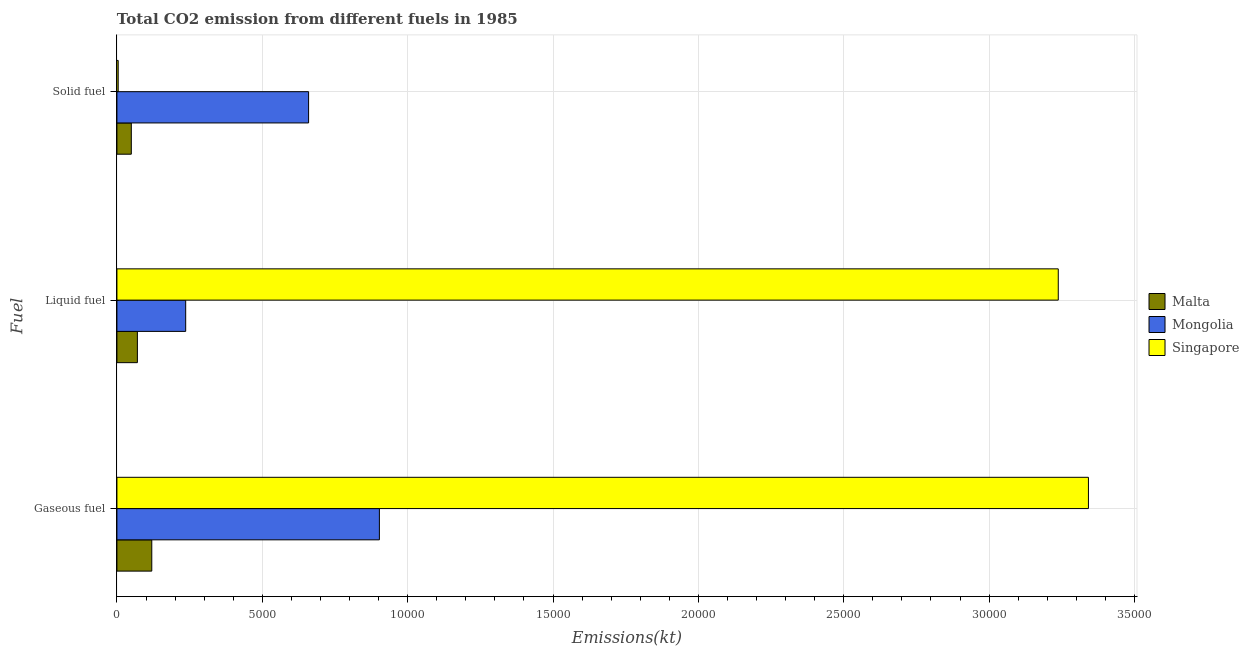How many different coloured bars are there?
Your answer should be compact. 3. How many groups of bars are there?
Ensure brevity in your answer.  3. Are the number of bars per tick equal to the number of legend labels?
Offer a terse response. Yes. Are the number of bars on each tick of the Y-axis equal?
Offer a terse response. Yes. How many bars are there on the 3rd tick from the top?
Your answer should be compact. 3. What is the label of the 2nd group of bars from the top?
Offer a terse response. Liquid fuel. What is the amount of co2 emissions from gaseous fuel in Mongolia?
Make the answer very short. 9028.15. Across all countries, what is the maximum amount of co2 emissions from liquid fuel?
Ensure brevity in your answer.  3.24e+04. Across all countries, what is the minimum amount of co2 emissions from gaseous fuel?
Keep it short and to the point. 1199.11. In which country was the amount of co2 emissions from solid fuel maximum?
Ensure brevity in your answer.  Mongolia. In which country was the amount of co2 emissions from gaseous fuel minimum?
Make the answer very short. Malta. What is the total amount of co2 emissions from liquid fuel in the graph?
Provide a succinct answer. 3.54e+04. What is the difference between the amount of co2 emissions from gaseous fuel in Malta and that in Singapore?
Your answer should be very brief. -3.22e+04. What is the difference between the amount of co2 emissions from solid fuel in Mongolia and the amount of co2 emissions from liquid fuel in Singapore?
Provide a short and direct response. -2.58e+04. What is the average amount of co2 emissions from solid fuel per country?
Give a very brief answer. 2377.44. What is the difference between the amount of co2 emissions from liquid fuel and amount of co2 emissions from solid fuel in Malta?
Give a very brief answer. 209.02. In how many countries, is the amount of co2 emissions from liquid fuel greater than 16000 kt?
Ensure brevity in your answer.  1. What is the ratio of the amount of co2 emissions from gaseous fuel in Mongolia to that in Singapore?
Provide a short and direct response. 0.27. Is the amount of co2 emissions from liquid fuel in Malta less than that in Mongolia?
Ensure brevity in your answer.  Yes. Is the difference between the amount of co2 emissions from solid fuel in Mongolia and Singapore greater than the difference between the amount of co2 emissions from liquid fuel in Mongolia and Singapore?
Make the answer very short. Yes. What is the difference between the highest and the second highest amount of co2 emissions from solid fuel?
Provide a short and direct response. 6098.22. What is the difference between the highest and the lowest amount of co2 emissions from gaseous fuel?
Make the answer very short. 3.22e+04. In how many countries, is the amount of co2 emissions from liquid fuel greater than the average amount of co2 emissions from liquid fuel taken over all countries?
Keep it short and to the point. 1. Is the sum of the amount of co2 emissions from liquid fuel in Singapore and Malta greater than the maximum amount of co2 emissions from gaseous fuel across all countries?
Keep it short and to the point. No. What does the 1st bar from the top in Gaseous fuel represents?
Ensure brevity in your answer.  Singapore. What does the 3rd bar from the bottom in Solid fuel represents?
Give a very brief answer. Singapore. How many countries are there in the graph?
Your answer should be compact. 3. What is the difference between two consecutive major ticks on the X-axis?
Provide a succinct answer. 5000. Are the values on the major ticks of X-axis written in scientific E-notation?
Provide a short and direct response. No. Does the graph contain grids?
Offer a terse response. Yes. Where does the legend appear in the graph?
Your answer should be very brief. Center right. How many legend labels are there?
Your answer should be compact. 3. How are the legend labels stacked?
Ensure brevity in your answer.  Vertical. What is the title of the graph?
Your answer should be compact. Total CO2 emission from different fuels in 1985. What is the label or title of the X-axis?
Offer a terse response. Emissions(kt). What is the label or title of the Y-axis?
Your answer should be compact. Fuel. What is the Emissions(kt) in Malta in Gaseous fuel?
Ensure brevity in your answer.  1199.11. What is the Emissions(kt) in Mongolia in Gaseous fuel?
Provide a succinct answer. 9028.15. What is the Emissions(kt) in Singapore in Gaseous fuel?
Ensure brevity in your answer.  3.34e+04. What is the Emissions(kt) in Malta in Liquid fuel?
Offer a very short reply. 704.06. What is the Emissions(kt) of Mongolia in Liquid fuel?
Keep it short and to the point. 2365.22. What is the Emissions(kt) of Singapore in Liquid fuel?
Provide a short and direct response. 3.24e+04. What is the Emissions(kt) of Malta in Solid fuel?
Ensure brevity in your answer.  495.05. What is the Emissions(kt) in Mongolia in Solid fuel?
Provide a succinct answer. 6593.27. What is the Emissions(kt) of Singapore in Solid fuel?
Make the answer very short. 44. Across all Fuel, what is the maximum Emissions(kt) of Malta?
Provide a succinct answer. 1199.11. Across all Fuel, what is the maximum Emissions(kt) in Mongolia?
Provide a short and direct response. 9028.15. Across all Fuel, what is the maximum Emissions(kt) in Singapore?
Give a very brief answer. 3.34e+04. Across all Fuel, what is the minimum Emissions(kt) in Malta?
Give a very brief answer. 495.05. Across all Fuel, what is the minimum Emissions(kt) in Mongolia?
Your answer should be compact. 2365.22. Across all Fuel, what is the minimum Emissions(kt) in Singapore?
Provide a short and direct response. 44. What is the total Emissions(kt) of Malta in the graph?
Offer a very short reply. 2398.22. What is the total Emissions(kt) in Mongolia in the graph?
Give a very brief answer. 1.80e+04. What is the total Emissions(kt) in Singapore in the graph?
Make the answer very short. 6.58e+04. What is the difference between the Emissions(kt) of Malta in Gaseous fuel and that in Liquid fuel?
Provide a succinct answer. 495.05. What is the difference between the Emissions(kt) in Mongolia in Gaseous fuel and that in Liquid fuel?
Your response must be concise. 6662.94. What is the difference between the Emissions(kt) in Singapore in Gaseous fuel and that in Liquid fuel?
Your answer should be compact. 1037.76. What is the difference between the Emissions(kt) in Malta in Gaseous fuel and that in Solid fuel?
Provide a short and direct response. 704.06. What is the difference between the Emissions(kt) in Mongolia in Gaseous fuel and that in Solid fuel?
Make the answer very short. 2434.89. What is the difference between the Emissions(kt) of Singapore in Gaseous fuel and that in Solid fuel?
Your response must be concise. 3.34e+04. What is the difference between the Emissions(kt) of Malta in Liquid fuel and that in Solid fuel?
Your answer should be compact. 209.02. What is the difference between the Emissions(kt) of Mongolia in Liquid fuel and that in Solid fuel?
Your answer should be very brief. -4228.05. What is the difference between the Emissions(kt) in Singapore in Liquid fuel and that in Solid fuel?
Provide a succinct answer. 3.23e+04. What is the difference between the Emissions(kt) of Malta in Gaseous fuel and the Emissions(kt) of Mongolia in Liquid fuel?
Your response must be concise. -1166.11. What is the difference between the Emissions(kt) of Malta in Gaseous fuel and the Emissions(kt) of Singapore in Liquid fuel?
Keep it short and to the point. -3.12e+04. What is the difference between the Emissions(kt) in Mongolia in Gaseous fuel and the Emissions(kt) in Singapore in Liquid fuel?
Offer a terse response. -2.34e+04. What is the difference between the Emissions(kt) in Malta in Gaseous fuel and the Emissions(kt) in Mongolia in Solid fuel?
Ensure brevity in your answer.  -5394.16. What is the difference between the Emissions(kt) of Malta in Gaseous fuel and the Emissions(kt) of Singapore in Solid fuel?
Your answer should be compact. 1155.11. What is the difference between the Emissions(kt) of Mongolia in Gaseous fuel and the Emissions(kt) of Singapore in Solid fuel?
Make the answer very short. 8984.15. What is the difference between the Emissions(kt) in Malta in Liquid fuel and the Emissions(kt) in Mongolia in Solid fuel?
Offer a very short reply. -5889.2. What is the difference between the Emissions(kt) in Malta in Liquid fuel and the Emissions(kt) in Singapore in Solid fuel?
Provide a succinct answer. 660.06. What is the difference between the Emissions(kt) in Mongolia in Liquid fuel and the Emissions(kt) in Singapore in Solid fuel?
Provide a short and direct response. 2321.21. What is the average Emissions(kt) in Malta per Fuel?
Your answer should be compact. 799.41. What is the average Emissions(kt) of Mongolia per Fuel?
Provide a succinct answer. 5995.55. What is the average Emissions(kt) in Singapore per Fuel?
Keep it short and to the point. 2.19e+04. What is the difference between the Emissions(kt) in Malta and Emissions(kt) in Mongolia in Gaseous fuel?
Keep it short and to the point. -7829.05. What is the difference between the Emissions(kt) of Malta and Emissions(kt) of Singapore in Gaseous fuel?
Provide a short and direct response. -3.22e+04. What is the difference between the Emissions(kt) of Mongolia and Emissions(kt) of Singapore in Gaseous fuel?
Ensure brevity in your answer.  -2.44e+04. What is the difference between the Emissions(kt) of Malta and Emissions(kt) of Mongolia in Liquid fuel?
Your answer should be compact. -1661.15. What is the difference between the Emissions(kt) in Malta and Emissions(kt) in Singapore in Liquid fuel?
Offer a very short reply. -3.17e+04. What is the difference between the Emissions(kt) of Mongolia and Emissions(kt) of Singapore in Liquid fuel?
Ensure brevity in your answer.  -3.00e+04. What is the difference between the Emissions(kt) of Malta and Emissions(kt) of Mongolia in Solid fuel?
Give a very brief answer. -6098.22. What is the difference between the Emissions(kt) of Malta and Emissions(kt) of Singapore in Solid fuel?
Offer a very short reply. 451.04. What is the difference between the Emissions(kt) in Mongolia and Emissions(kt) in Singapore in Solid fuel?
Your answer should be compact. 6549.26. What is the ratio of the Emissions(kt) of Malta in Gaseous fuel to that in Liquid fuel?
Offer a very short reply. 1.7. What is the ratio of the Emissions(kt) of Mongolia in Gaseous fuel to that in Liquid fuel?
Your answer should be compact. 3.82. What is the ratio of the Emissions(kt) in Singapore in Gaseous fuel to that in Liquid fuel?
Offer a very short reply. 1.03. What is the ratio of the Emissions(kt) of Malta in Gaseous fuel to that in Solid fuel?
Your answer should be compact. 2.42. What is the ratio of the Emissions(kt) in Mongolia in Gaseous fuel to that in Solid fuel?
Ensure brevity in your answer.  1.37. What is the ratio of the Emissions(kt) in Singapore in Gaseous fuel to that in Solid fuel?
Make the answer very short. 759.42. What is the ratio of the Emissions(kt) in Malta in Liquid fuel to that in Solid fuel?
Your answer should be very brief. 1.42. What is the ratio of the Emissions(kt) in Mongolia in Liquid fuel to that in Solid fuel?
Offer a very short reply. 0.36. What is the ratio of the Emissions(kt) in Singapore in Liquid fuel to that in Solid fuel?
Provide a succinct answer. 735.83. What is the difference between the highest and the second highest Emissions(kt) in Malta?
Keep it short and to the point. 495.05. What is the difference between the highest and the second highest Emissions(kt) of Mongolia?
Offer a terse response. 2434.89. What is the difference between the highest and the second highest Emissions(kt) in Singapore?
Provide a short and direct response. 1037.76. What is the difference between the highest and the lowest Emissions(kt) of Malta?
Your answer should be very brief. 704.06. What is the difference between the highest and the lowest Emissions(kt) in Mongolia?
Your response must be concise. 6662.94. What is the difference between the highest and the lowest Emissions(kt) in Singapore?
Your response must be concise. 3.34e+04. 